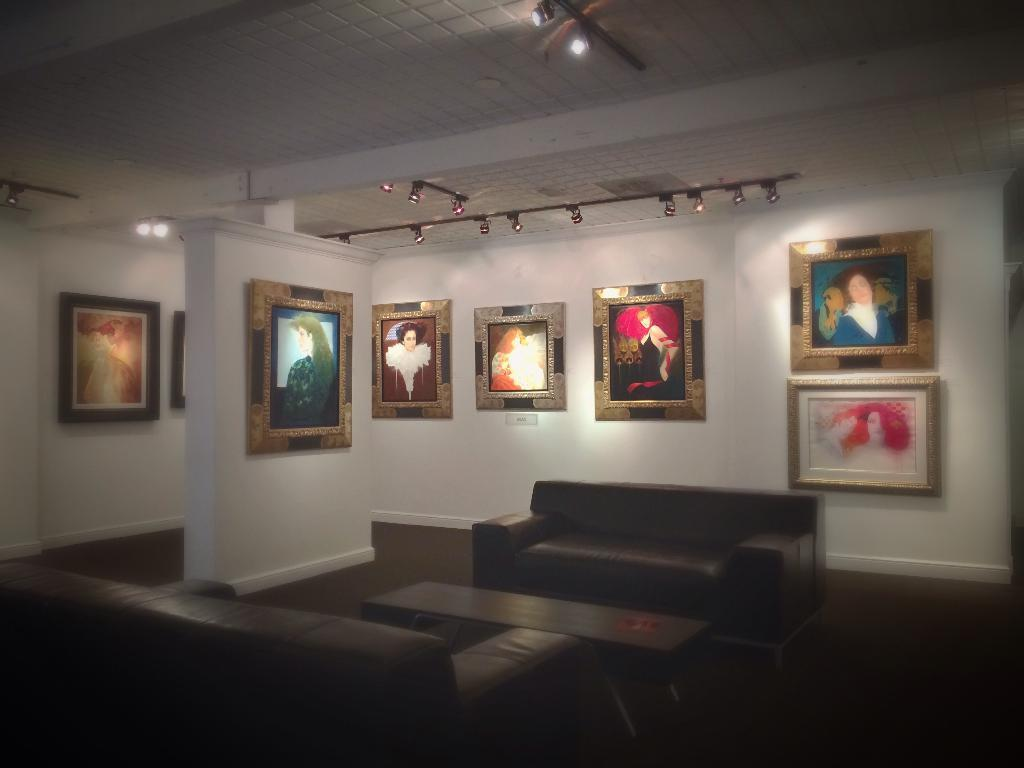What is the main piece of furniture in the image? There is a couch in the center of the image. What can be seen behind the couch? There is a wall in the background of the image. What is hanging on the wall? There are photo frames on the wall. Where is the stove located in the image? There is no stove present in the image. Who is the representative in the image? The image does not depict a person or a representative. 